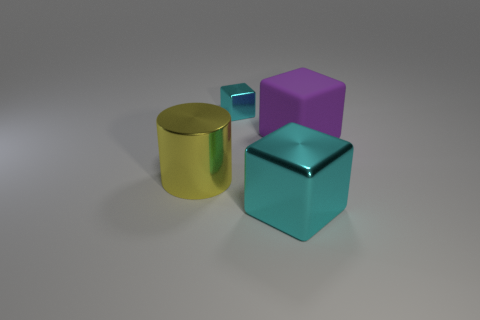What number of cyan objects are either large rubber objects or big spheres?
Give a very brief answer. 0. There is a shiny thing on the right side of the cyan metal cube that is behind the big purple cube; what is its shape?
Provide a succinct answer. Cube. There is a matte thing that is the same size as the yellow metal object; what shape is it?
Offer a terse response. Cube. Are there any other objects that have the same color as the rubber object?
Make the answer very short. No. Is the number of big cyan shiny cubes on the right side of the small cyan metal block the same as the number of cyan shiny blocks right of the purple thing?
Make the answer very short. No. There is a rubber object; is its shape the same as the cyan metal object that is behind the rubber cube?
Provide a short and direct response. Yes. What number of other objects are the same material as the purple block?
Provide a succinct answer. 0. There is a small thing; are there any tiny metallic things in front of it?
Make the answer very short. No. Do the metallic cylinder and the cyan shiny object behind the large cylinder have the same size?
Your answer should be compact. No. The large object right of the block in front of the yellow cylinder is what color?
Your answer should be very brief. Purple. 